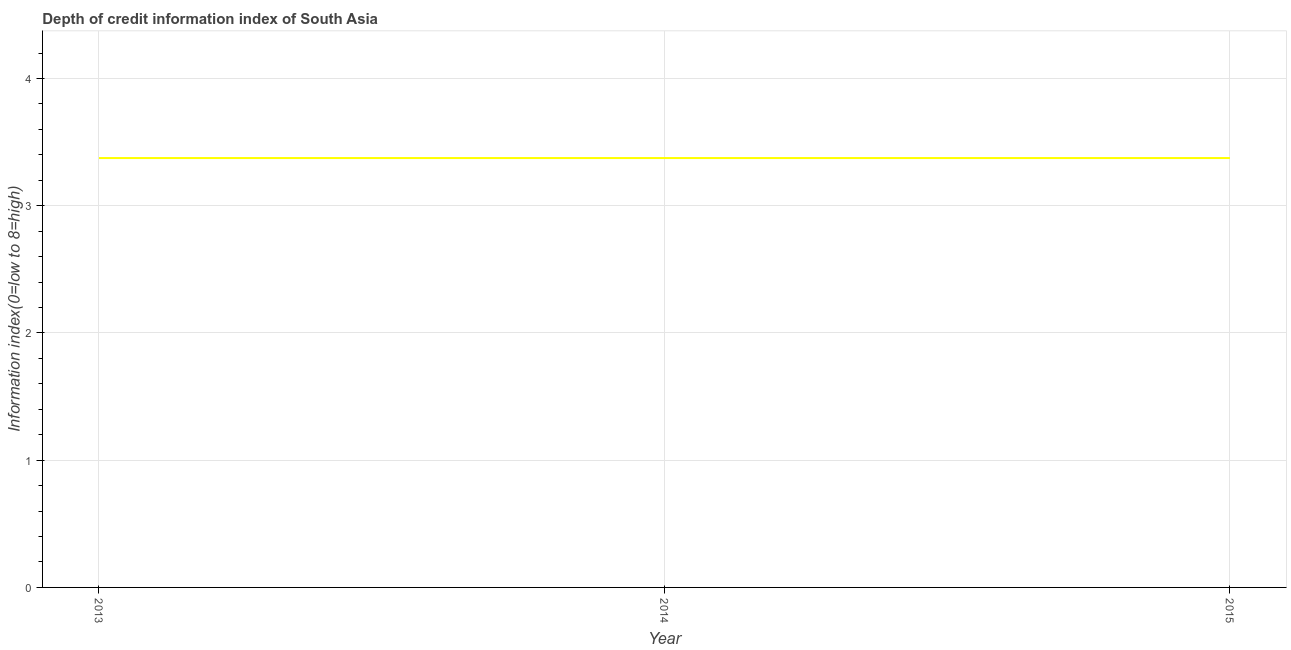What is the depth of credit information index in 2013?
Ensure brevity in your answer.  3.38. Across all years, what is the maximum depth of credit information index?
Offer a very short reply. 3.38. Across all years, what is the minimum depth of credit information index?
Ensure brevity in your answer.  3.38. In which year was the depth of credit information index maximum?
Provide a succinct answer. 2013. In which year was the depth of credit information index minimum?
Make the answer very short. 2013. What is the sum of the depth of credit information index?
Ensure brevity in your answer.  10.12. What is the average depth of credit information index per year?
Offer a very short reply. 3.38. What is the median depth of credit information index?
Make the answer very short. 3.38. In how many years, is the depth of credit information index greater than 4 ?
Offer a very short reply. 0. Do a majority of the years between 2013 and 2014 (inclusive) have depth of credit information index greater than 0.8 ?
Ensure brevity in your answer.  Yes. Is the depth of credit information index in 2013 less than that in 2014?
Offer a very short reply. No. Is the sum of the depth of credit information index in 2013 and 2015 greater than the maximum depth of credit information index across all years?
Keep it short and to the point. Yes. Does the depth of credit information index monotonically increase over the years?
Make the answer very short. No. How many years are there in the graph?
Your response must be concise. 3. Are the values on the major ticks of Y-axis written in scientific E-notation?
Offer a terse response. No. What is the title of the graph?
Your answer should be compact. Depth of credit information index of South Asia. What is the label or title of the Y-axis?
Keep it short and to the point. Information index(0=low to 8=high). What is the Information index(0=low to 8=high) in 2013?
Ensure brevity in your answer.  3.38. What is the Information index(0=low to 8=high) of 2014?
Offer a terse response. 3.38. What is the Information index(0=low to 8=high) in 2015?
Your answer should be very brief. 3.38. What is the difference between the Information index(0=low to 8=high) in 2013 and 2014?
Your answer should be compact. 0. What is the difference between the Information index(0=low to 8=high) in 2013 and 2015?
Keep it short and to the point. 0. What is the difference between the Information index(0=low to 8=high) in 2014 and 2015?
Provide a succinct answer. 0. What is the ratio of the Information index(0=low to 8=high) in 2013 to that in 2015?
Provide a succinct answer. 1. 